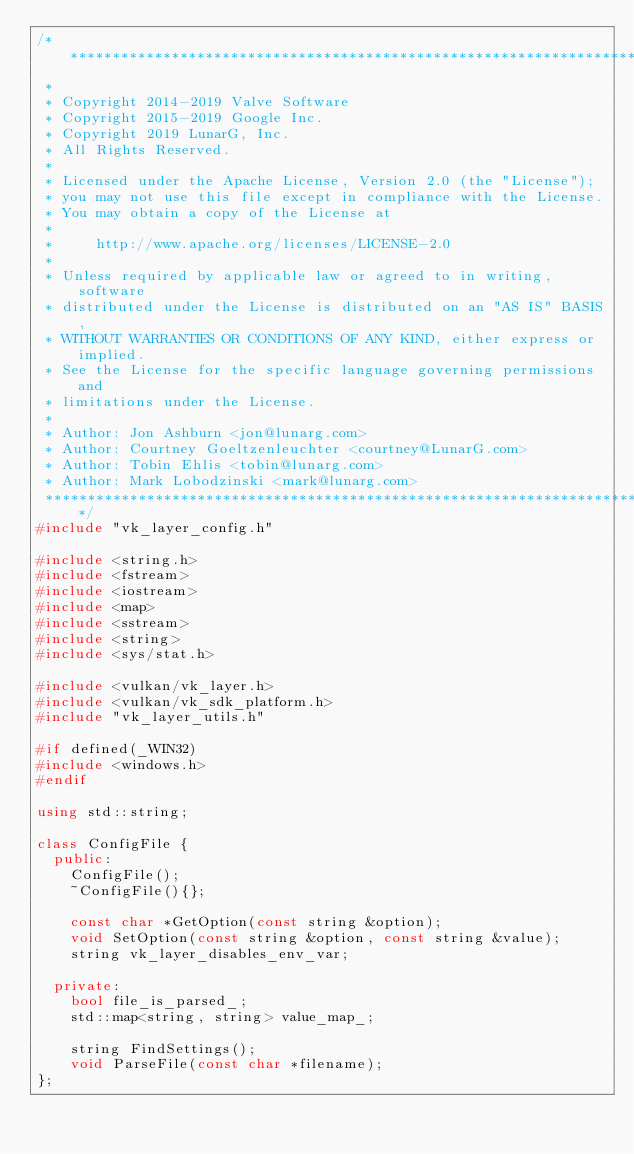<code> <loc_0><loc_0><loc_500><loc_500><_C++_>/**************************************************************************
 *
 * Copyright 2014-2019 Valve Software
 * Copyright 2015-2019 Google Inc.
 * Copyright 2019 LunarG, Inc.
 * All Rights Reserved.
 *
 * Licensed under the Apache License, Version 2.0 (the "License");
 * you may not use this file except in compliance with the License.
 * You may obtain a copy of the License at
 *
 *     http://www.apache.org/licenses/LICENSE-2.0
 *
 * Unless required by applicable law or agreed to in writing, software
 * distributed under the License is distributed on an "AS IS" BASIS,
 * WITHOUT WARRANTIES OR CONDITIONS OF ANY KIND, either express or implied.
 * See the License for the specific language governing permissions and
 * limitations under the License.
 *
 * Author: Jon Ashburn <jon@lunarg.com>
 * Author: Courtney Goeltzenleuchter <courtney@LunarG.com>
 * Author: Tobin Ehlis <tobin@lunarg.com>
 * Author: Mark Lobodzinski <mark@lunarg.com>
 **************************************************************************/
#include "vk_layer_config.h"

#include <string.h>
#include <fstream>
#include <iostream>
#include <map>
#include <sstream>
#include <string>
#include <sys/stat.h>

#include <vulkan/vk_layer.h>
#include <vulkan/vk_sdk_platform.h>
#include "vk_layer_utils.h"

#if defined(_WIN32)
#include <windows.h>
#endif

using std::string;

class ConfigFile {
  public:
    ConfigFile();
    ~ConfigFile(){};

    const char *GetOption(const string &option);
    void SetOption(const string &option, const string &value);
    string vk_layer_disables_env_var;

  private:
    bool file_is_parsed_;
    std::map<string, string> value_map_;

    string FindSettings();
    void ParseFile(const char *filename);
};
</code> 